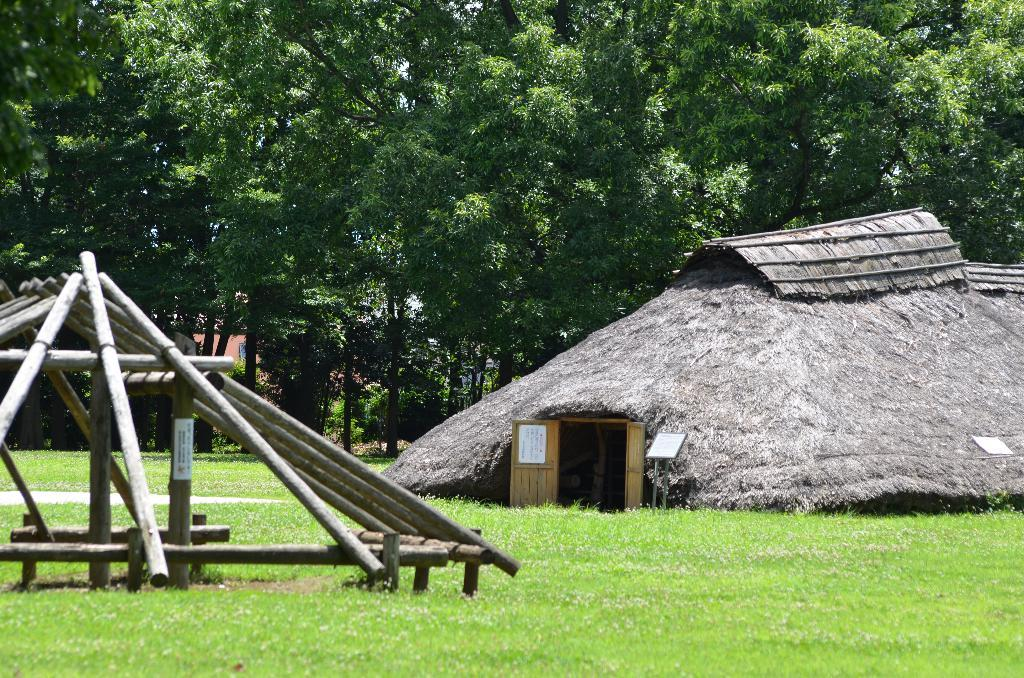What type of vegetation is present on the ground in the image? There is green color grass on the ground in the image. What structure can be seen on the right side of the image? There is a house at the right side of the image. Does the house have any entrance? Yes, the house has a door. What other type of vegetation is present in the image besides grass? There are green color trees in the image. How many legs does the pet have in the image? There is no pet present in the image, so it is not possible to determine the number of legs. 